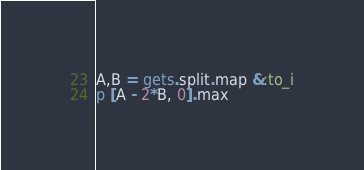Convert code to text. <code><loc_0><loc_0><loc_500><loc_500><_Ruby_>A,B = gets.split.map &:to_i
p [A - 2*B, 0].max</code> 